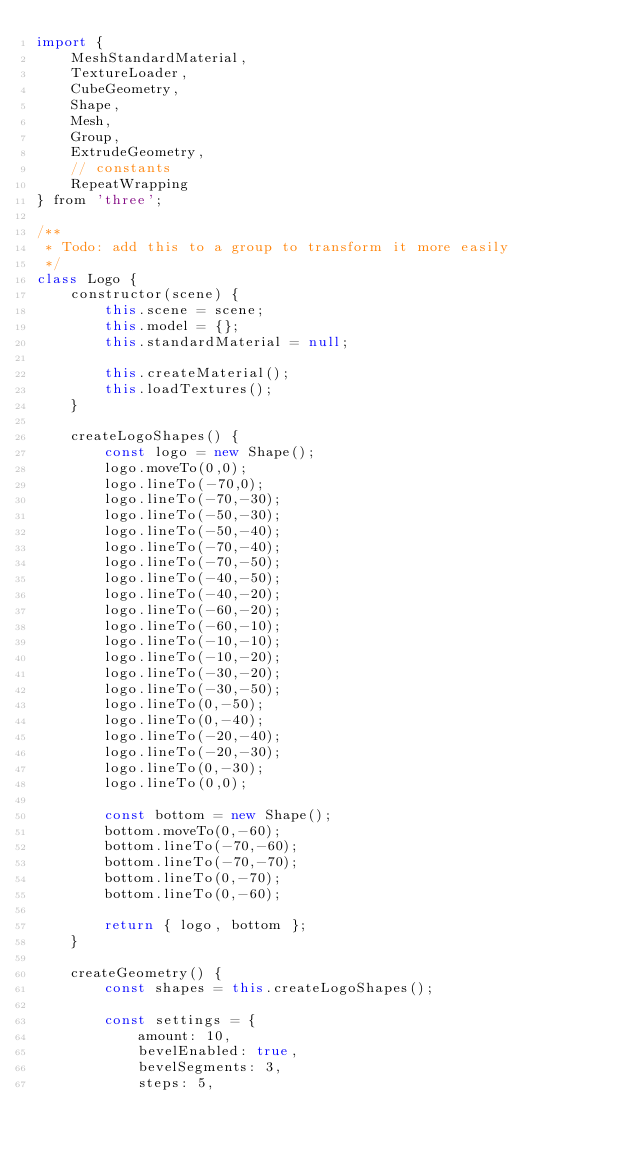<code> <loc_0><loc_0><loc_500><loc_500><_JavaScript_>import {
    MeshStandardMaterial,
    TextureLoader,
    CubeGeometry,
    Shape,
    Mesh,
    Group,
    ExtrudeGeometry,
    // constants
    RepeatWrapping
} from 'three';

/**
 * Todo: add this to a group to transform it more easily
 */
class Logo {
    constructor(scene) {
        this.scene = scene;
        this.model = {};
        this.standardMaterial = null;
        
        this.createMaterial();
        this.loadTextures();
    }
    
    createLogoShapes() {
        const logo = new Shape();
        logo.moveTo(0,0);
        logo.lineTo(-70,0);
        logo.lineTo(-70,-30);
        logo.lineTo(-50,-30);
        logo.lineTo(-50,-40);
        logo.lineTo(-70,-40);
        logo.lineTo(-70,-50);
        logo.lineTo(-40,-50);
        logo.lineTo(-40,-20);
        logo.lineTo(-60,-20);
        logo.lineTo(-60,-10);
        logo.lineTo(-10,-10);
        logo.lineTo(-10,-20);
        logo.lineTo(-30,-20);
        logo.lineTo(-30,-50);
        logo.lineTo(0,-50);
        logo.lineTo(0,-40);
        logo.lineTo(-20,-40);
        logo.lineTo(-20,-30);
        logo.lineTo(0,-30);
        logo.lineTo(0,0);

        const bottom = new Shape();
        bottom.moveTo(0,-60);
        bottom.lineTo(-70,-60);
        bottom.lineTo(-70,-70);
        bottom.lineTo(0,-70);
        bottom.lineTo(0,-60);

        return { logo, bottom };
    }
    
    createGeometry() {
        const shapes = this.createLogoShapes();

        const settings = { 
            amount: 10, 
            bevelEnabled: true, 
            bevelSegments: 3, 
            steps: 5, </code> 